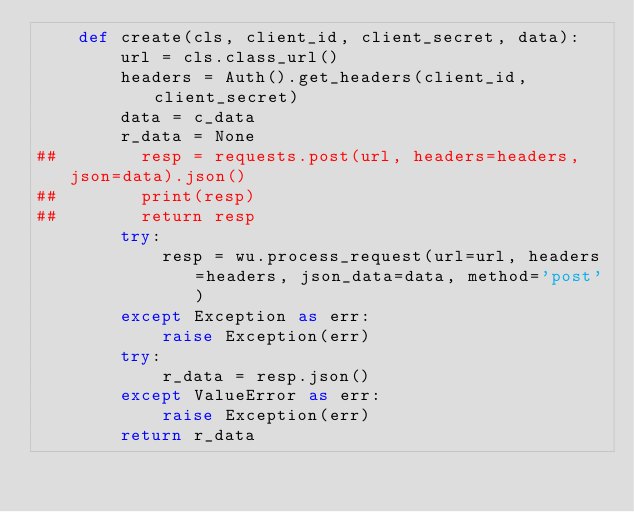<code> <loc_0><loc_0><loc_500><loc_500><_Python_>    def create(cls, client_id, client_secret, data):
        url = cls.class_url()
        headers = Auth().get_headers(client_id, client_secret)
        data = c_data
        r_data = None
##        resp = requests.post(url, headers=headers, json=data).json()
##        print(resp)
##        return resp
        try:
            resp = wu.process_request(url=url, headers=headers, json_data=data, method='post')
        except Exception as err:
            raise Exception(err)
        try:
            r_data = resp.json()
        except ValueError as err:
            raise Exception(err)
        return r_data
</code> 